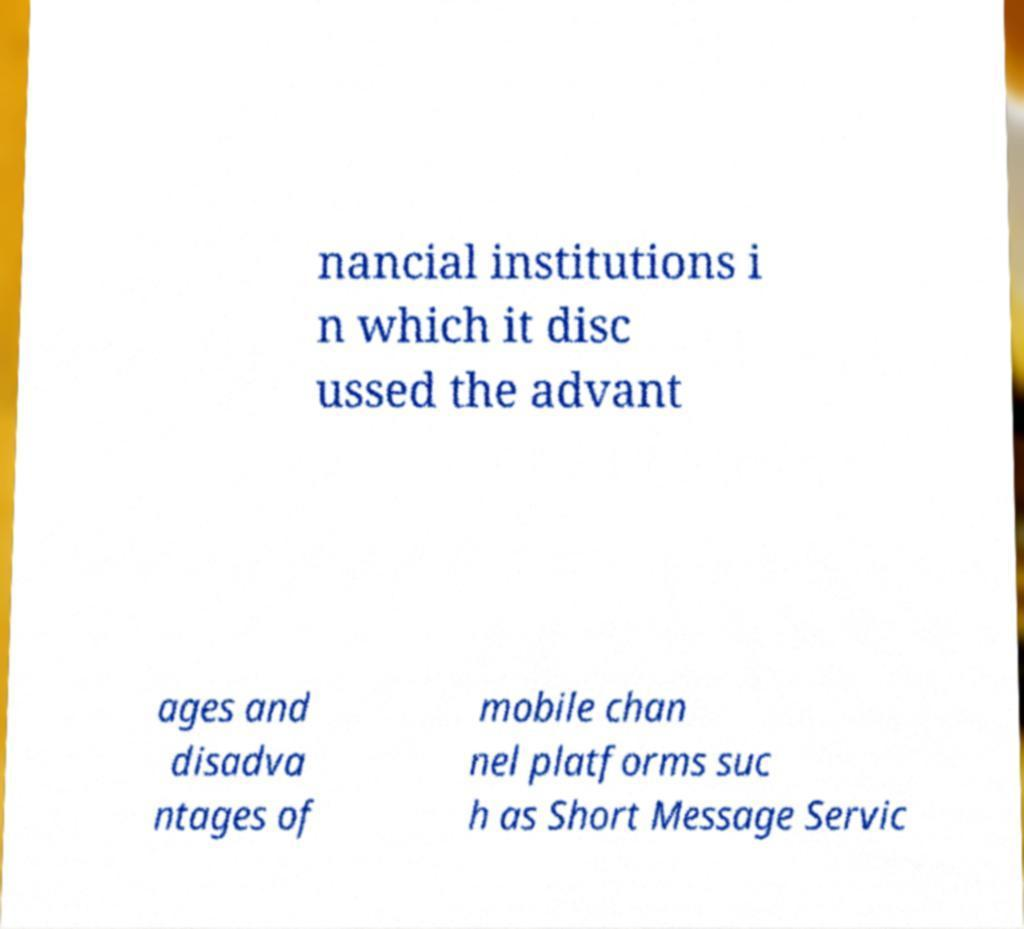I need the written content from this picture converted into text. Can you do that? nancial institutions i n which it disc ussed the advant ages and disadva ntages of mobile chan nel platforms suc h as Short Message Servic 